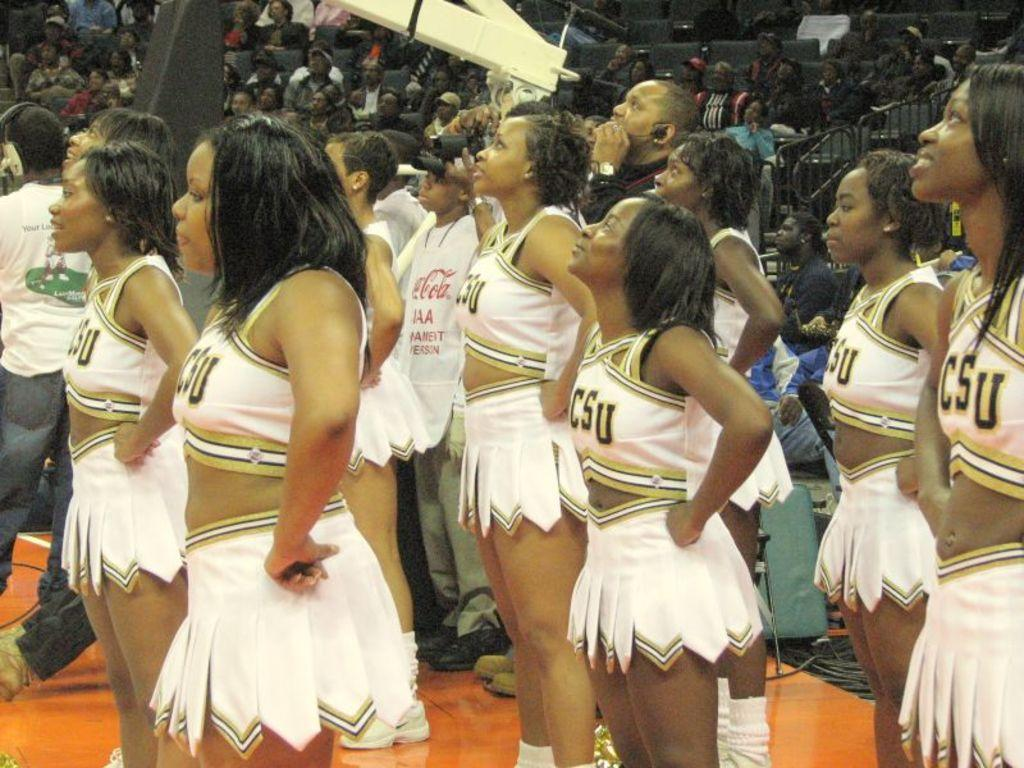<image>
Provide a brief description of the given image. Cheerleaders wearing a top that says CSU and has their hands on their sides. 